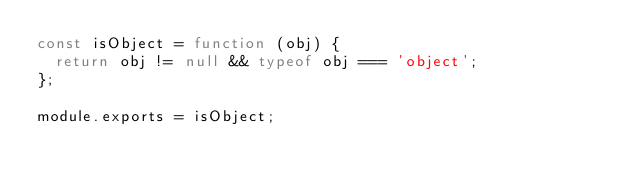Convert code to text. <code><loc_0><loc_0><loc_500><loc_500><_JavaScript_>const isObject = function (obj) {
  return obj != null && typeof obj === 'object';
};

module.exports = isObject;</code> 